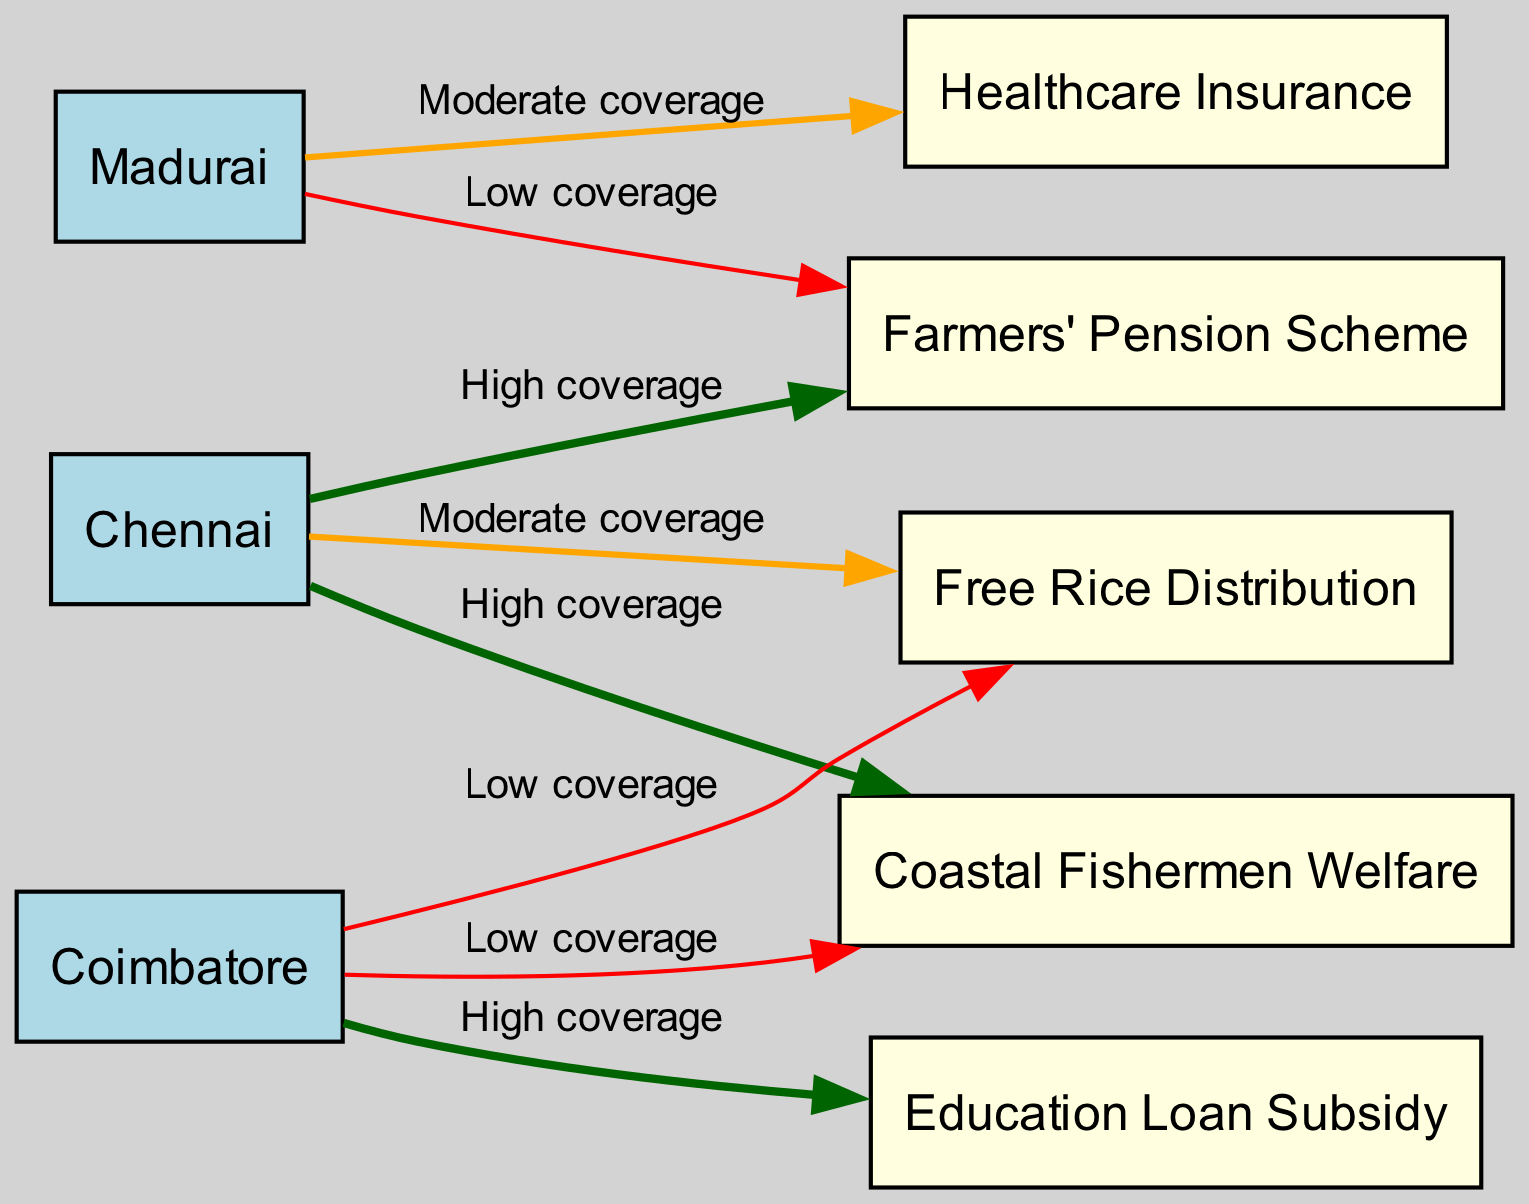What is the coverage label for the Farmers' Pension Scheme in Chennai? The diagram indicates a “High coverage” label for the Farmers' Pension Scheme connected to Chennai. This can be identified by locating the edge that connects the node for Chennai to the Farmers' Pension Scheme and reading the label.
Answer: High coverage Which region has low coverage for Free Rice Distribution? The diagram shows a “Low coverage” label connected to Coimbatore for the Free Rice Distribution scheme. To answer, one needs to find the node for Coimbatore and look at its connections to determine the coverage level.
Answer: Coimbatore How many social welfare schemes are listed in the diagram? Counting the nodes labeled as schemes yields a total of five social welfare schemes: Farmers' Pension Scheme, Free Rice Distribution, Education Loan Subsidy, Healthcare Insurance, and Coastal Fishermen Welfare. Each scheme node is distinct and easily identifiable.
Answer: 5 Which region has moderate coverage for Healthcare Insurance? The diagram illustrates that Madurai is connected to Healthcare Insurance with a “Moderate coverage” label. By checking the edge from Madurai to Healthcare Insurance, this information can be confirmed.
Answer: Madurai What is the relationship label for Chennai and Coastal Fishermen Welfare? The edge connecting Chennai to Coastal Fishermen Welfare is labeled “High coverage.” By locating the edge and observing its label, one can derive the relationship between the two nodes.
Answer: High coverage Which scheme has high coverage in Coimbatore? According to the diagram, the Education Loan Subsidy is the only scheme with a “High coverage” label connected to Coimbatore. This is determined by identifying the connections from Coimbatore and checking their associated coverage labels.
Answer: Education Loan Subsidy Which region exhibits moderate coverage for Free Rice Distribution? The diagram does not indicate any region with moderate coverage for Free Rice Distribution; instead, it shows only Chennai with “Moderate coverage” and Coimbatore with “Low coverage.” Thus, we find that no region has “Moderate coverage” specifically for this scheme.
Answer: None How many edges are connected to Chennai? Examining the diagram reveals that Chennai is connected by three edges: one each for Farmers' Pension Scheme, Free Rice Distribution, and Coastal Fishermen Welfare. This can be discerned by counting the outgoing edges from the node labeled Chennai.
Answer: 3 What indicates the coverage level for Education Loan Subsidy in Coimbatore? The diagram specifies a “High coverage” label for the Education Loan Subsidy that is linked to Coimbatore. Therefore, observing the edge from Coimbatore to this scheme and reading its label confirms the coverage level.
Answer: High coverage 